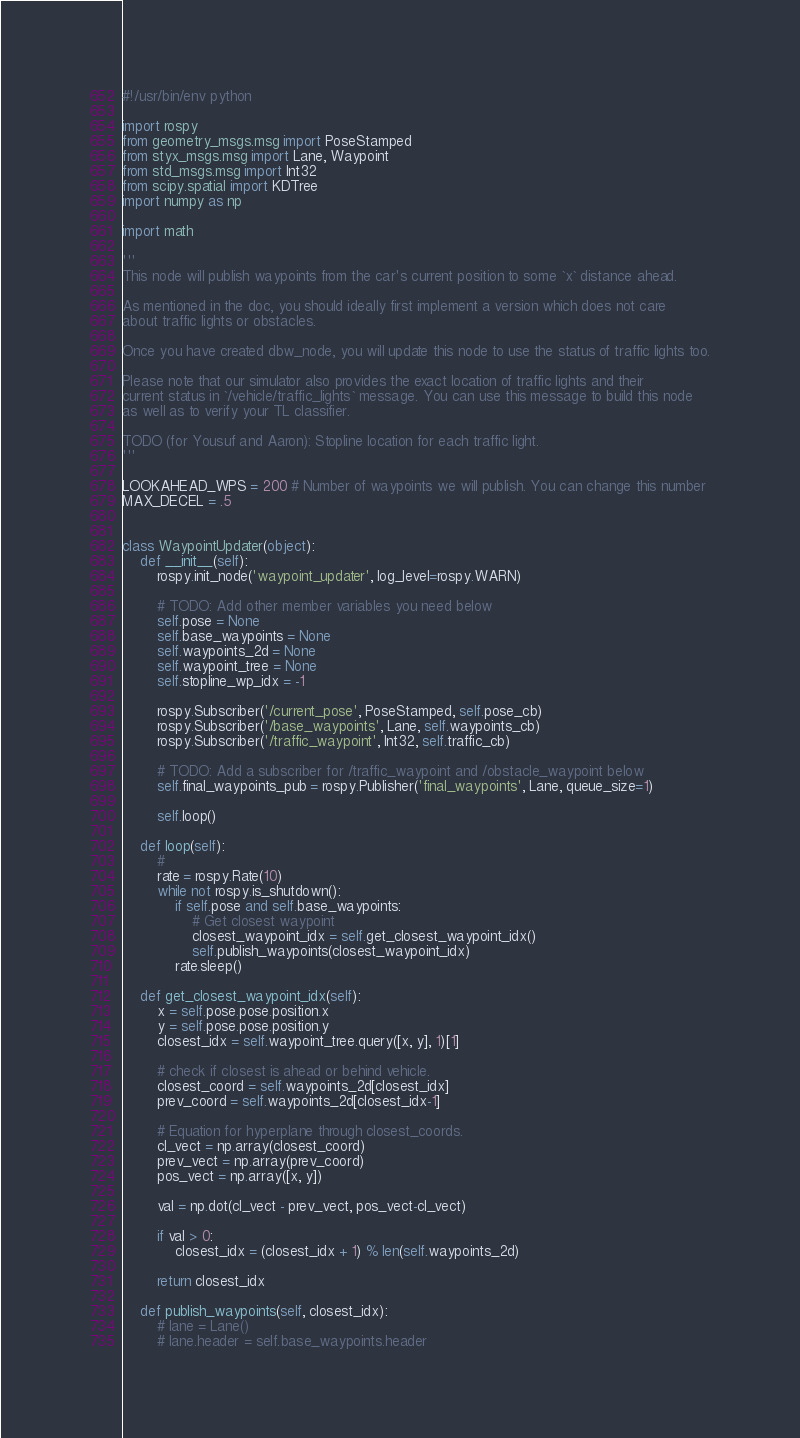<code> <loc_0><loc_0><loc_500><loc_500><_Python_>#!/usr/bin/env python

import rospy
from geometry_msgs.msg import PoseStamped
from styx_msgs.msg import Lane, Waypoint
from std_msgs.msg import Int32
from scipy.spatial import KDTree
import numpy as np

import math

'''
This node will publish waypoints from the car's current position to some `x` distance ahead.

As mentioned in the doc, you should ideally first implement a version which does not care
about traffic lights or obstacles.

Once you have created dbw_node, you will update this node to use the status of traffic lights too.

Please note that our simulator also provides the exact location of traffic lights and their
current status in `/vehicle/traffic_lights` message. You can use this message to build this node
as well as to verify your TL classifier.

TODO (for Yousuf and Aaron): Stopline location for each traffic light.
'''

LOOKAHEAD_WPS = 200 # Number of waypoints we will publish. You can change this number
MAX_DECEL = .5


class WaypointUpdater(object):
    def __init__(self):
        rospy.init_node('waypoint_updater', log_level=rospy.WARN)

        # TODO: Add other member variables you need below
        self.pose = None
        self.base_waypoints = None
        self.waypoints_2d = None
        self.waypoint_tree = None
        self.stopline_wp_idx = -1

        rospy.Subscriber('/current_pose', PoseStamped, self.pose_cb)
        rospy.Subscriber('/base_waypoints', Lane, self.waypoints_cb)
        rospy.Subscriber('/traffic_waypoint', Int32, self.traffic_cb)

        # TODO: Add a subscriber for /traffic_waypoint and /obstacle_waypoint below
        self.final_waypoints_pub = rospy.Publisher('final_waypoints', Lane, queue_size=1)

        self.loop()

    def loop(self):
        # 
        rate = rospy.Rate(10)
        while not rospy.is_shutdown():
            if self.pose and self.base_waypoints:
                # Get closest waypoint
                closest_waypoint_idx = self.get_closest_waypoint_idx()
                self.publish_waypoints(closest_waypoint_idx)
            rate.sleep()

    def get_closest_waypoint_idx(self):
        x = self.pose.pose.position.x
        y = self.pose.pose.position.y
        closest_idx = self.waypoint_tree.query([x, y], 1)[1]

        # check if closest is ahead or behind vehicle.
        closest_coord = self.waypoints_2d[closest_idx]
        prev_coord = self.waypoints_2d[closest_idx-1]

        # Equation for hyperplane through closest_coords.
        cl_vect = np.array(closest_coord)
        prev_vect = np.array(prev_coord)
        pos_vect = np.array([x, y])

        val = np.dot(cl_vect - prev_vect, pos_vect-cl_vect)

        if val > 0:
            closest_idx = (closest_idx + 1) % len(self.waypoints_2d)

        return closest_idx

    def publish_waypoints(self, closest_idx):
        # lane = Lane()
        # lane.header = self.base_waypoints.header</code> 